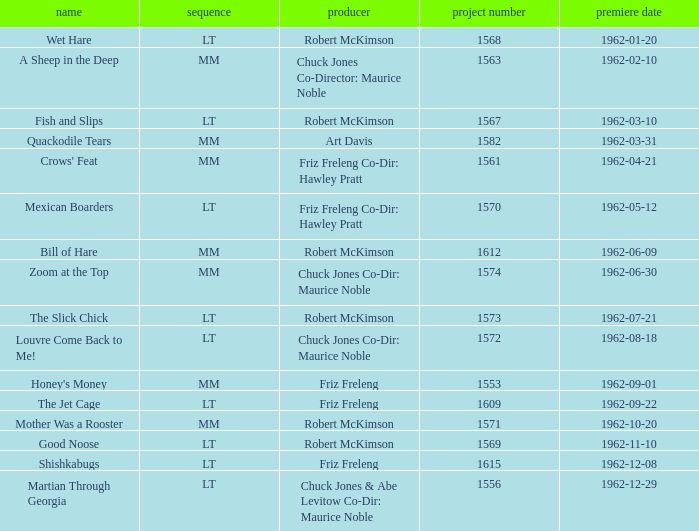What date was Wet Hare, directed by Robert McKimson, released? 1962-01-20. 